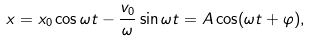<formula> <loc_0><loc_0><loc_500><loc_500>x = x _ { 0 } \cos \omega t - \frac { v _ { 0 } } \omega \sin \omega t = A \cos ( \omega t + \varphi ) ,</formula> 